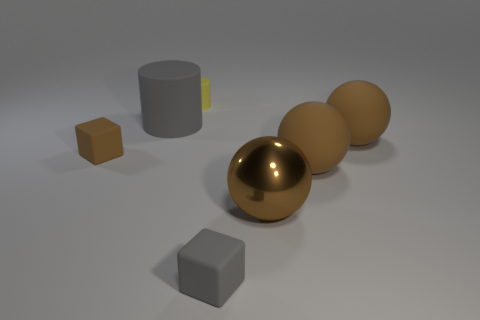There is a cylinder behind the large thing that is on the left side of the yellow cylinder; how many tiny rubber objects are right of it? In the image, the large object to the left of the yellow cylinder is a grey cube. To the right of this cube, there is one small yellow cube, which could be considered as the tiny rubber object mentioned. So, there is one tiny rubber object to the right of the grey cube. 